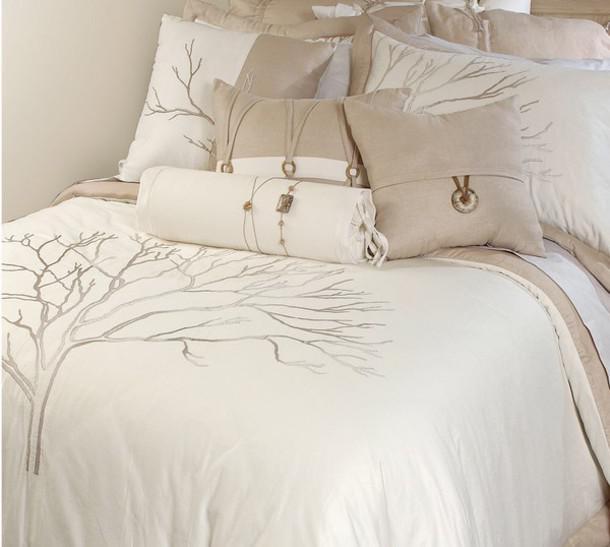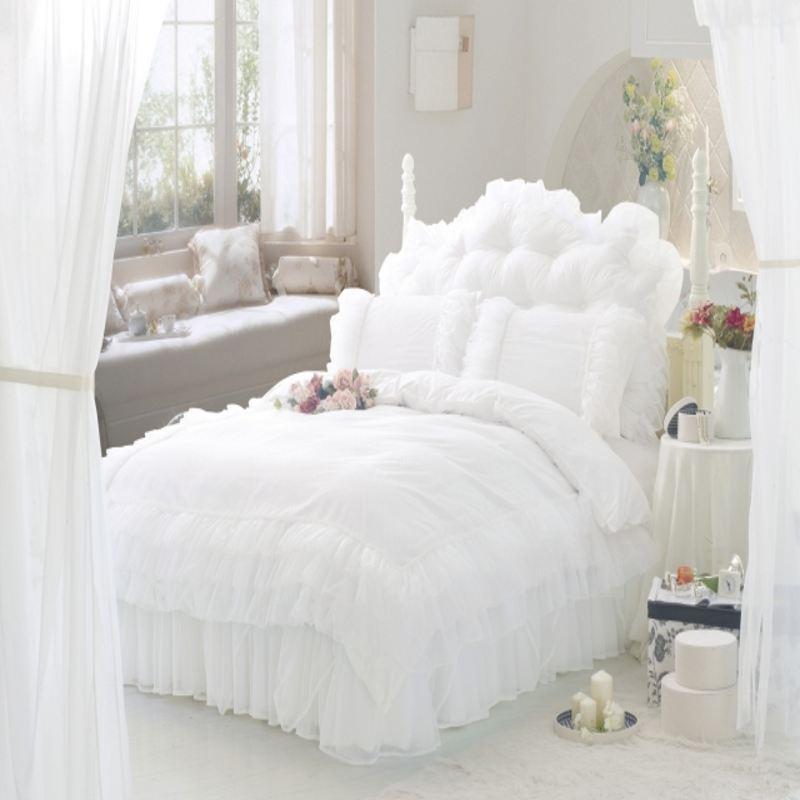The first image is the image on the left, the second image is the image on the right. Given the left and right images, does the statement "There are lamps on each side of a bed" hold true? Answer yes or no. No. The first image is the image on the left, the second image is the image on the right. Given the left and right images, does the statement "An image of a bedroom features bare branches somewhere in the decor." hold true? Answer yes or no. Yes. 